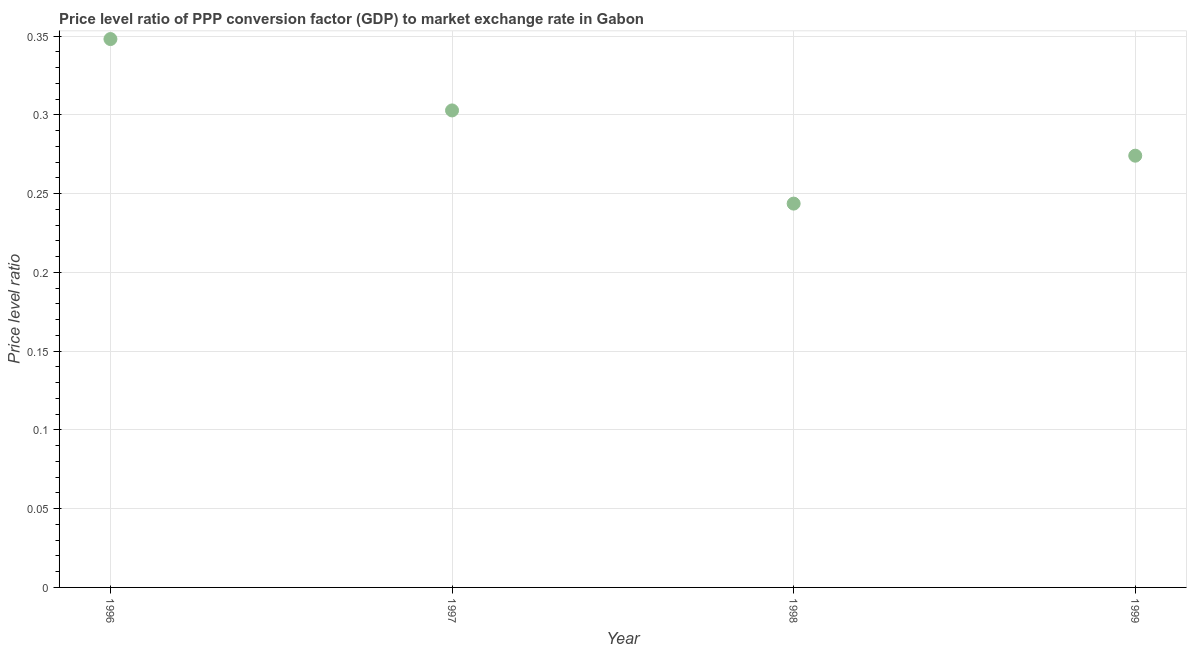What is the price level ratio in 1996?
Make the answer very short. 0.35. Across all years, what is the maximum price level ratio?
Offer a terse response. 0.35. Across all years, what is the minimum price level ratio?
Your answer should be compact. 0.24. In which year was the price level ratio minimum?
Give a very brief answer. 1998. What is the sum of the price level ratio?
Offer a very short reply. 1.17. What is the difference between the price level ratio in 1996 and 1997?
Your answer should be very brief. 0.05. What is the average price level ratio per year?
Keep it short and to the point. 0.29. What is the median price level ratio?
Ensure brevity in your answer.  0.29. What is the ratio of the price level ratio in 1997 to that in 1998?
Your response must be concise. 1.24. Is the price level ratio in 1996 less than that in 1998?
Offer a terse response. No. Is the difference between the price level ratio in 1996 and 1997 greater than the difference between any two years?
Provide a short and direct response. No. What is the difference between the highest and the second highest price level ratio?
Offer a very short reply. 0.05. Is the sum of the price level ratio in 1996 and 1999 greater than the maximum price level ratio across all years?
Offer a very short reply. Yes. What is the difference between the highest and the lowest price level ratio?
Your answer should be compact. 0.1. What is the difference between two consecutive major ticks on the Y-axis?
Make the answer very short. 0.05. Does the graph contain grids?
Offer a very short reply. Yes. What is the title of the graph?
Provide a succinct answer. Price level ratio of PPP conversion factor (GDP) to market exchange rate in Gabon. What is the label or title of the X-axis?
Ensure brevity in your answer.  Year. What is the label or title of the Y-axis?
Give a very brief answer. Price level ratio. What is the Price level ratio in 1996?
Make the answer very short. 0.35. What is the Price level ratio in 1997?
Make the answer very short. 0.3. What is the Price level ratio in 1998?
Make the answer very short. 0.24. What is the Price level ratio in 1999?
Give a very brief answer. 0.27. What is the difference between the Price level ratio in 1996 and 1997?
Your answer should be compact. 0.05. What is the difference between the Price level ratio in 1996 and 1998?
Provide a succinct answer. 0.1. What is the difference between the Price level ratio in 1996 and 1999?
Provide a succinct answer. 0.07. What is the difference between the Price level ratio in 1997 and 1998?
Your answer should be very brief. 0.06. What is the difference between the Price level ratio in 1997 and 1999?
Your answer should be very brief. 0.03. What is the difference between the Price level ratio in 1998 and 1999?
Your answer should be compact. -0.03. What is the ratio of the Price level ratio in 1996 to that in 1997?
Offer a very short reply. 1.15. What is the ratio of the Price level ratio in 1996 to that in 1998?
Provide a short and direct response. 1.43. What is the ratio of the Price level ratio in 1996 to that in 1999?
Provide a short and direct response. 1.27. What is the ratio of the Price level ratio in 1997 to that in 1998?
Keep it short and to the point. 1.24. What is the ratio of the Price level ratio in 1997 to that in 1999?
Keep it short and to the point. 1.1. What is the ratio of the Price level ratio in 1998 to that in 1999?
Make the answer very short. 0.89. 